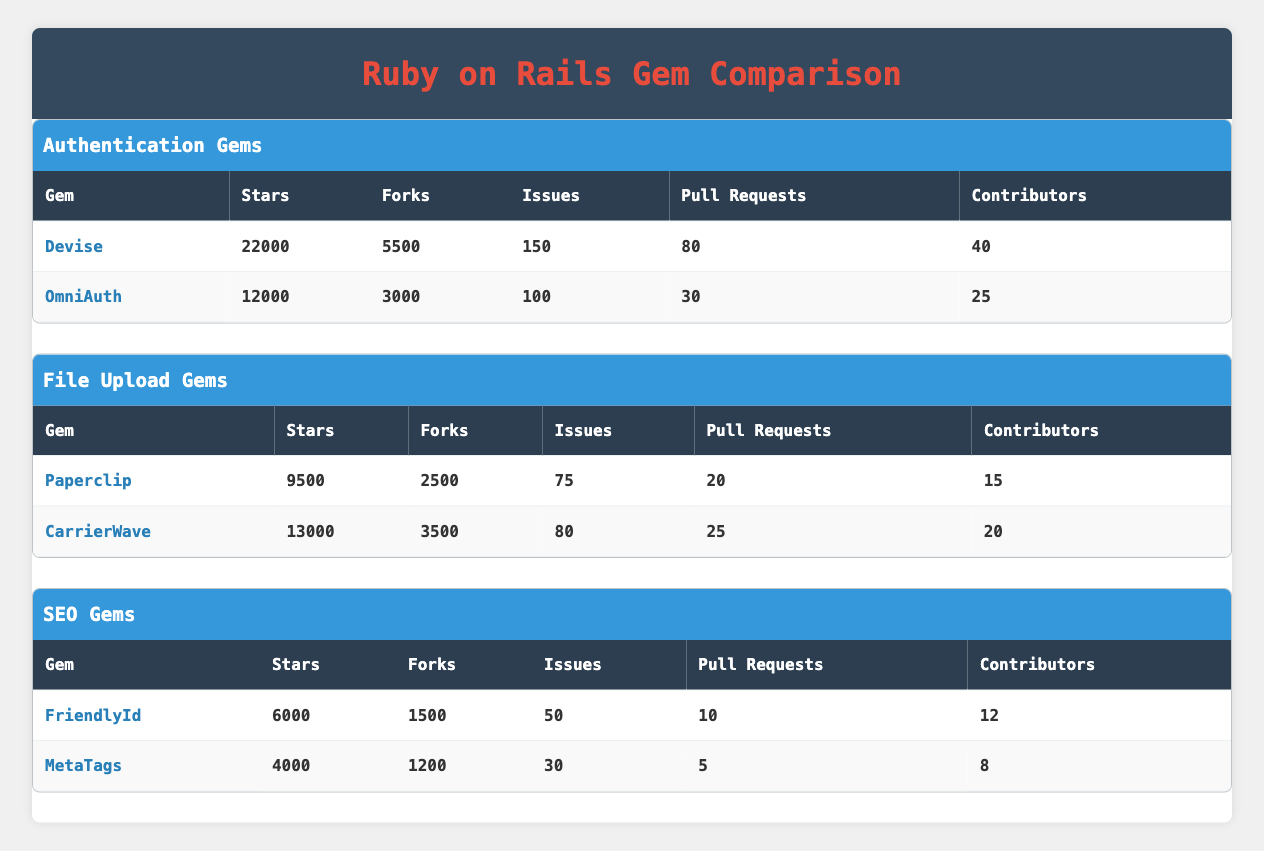What gem has the most stars in the Authentication Gems category? By looking at the "Stars" column under the "Authentication Gems" category, we see that Devise has 22000 stars, while OmniAuth has 12000 stars. Since 22000 is greater than 12000, the gem with the most stars is Devise.
Answer: Devise How many contributors does the File Upload Gems category have in total? To find the total contributors in the "File Upload Gems" category, we add the number of contributors for both gems: Paperclip has 15 contributors and CarrierWave has 20 contributors. So, the total is 15 + 20 = 35.
Answer: 35 Is it true that MetaTags has more forks than FriendlyId? Looking under the "Forks" column for the SEO Gems category, MetaTags has 1200 forks while FriendlyId has 1500 forks. Therefore, it is false that MetaTags has more forks than FriendlyId.
Answer: No What is the average number of issues in the Authentication Gems category? In the Authentication Gems category, Devise has 150 issues and OmniAuth has 100 issues. To calculate the average, we sum the issues: 150 + 100 = 250, and then divide by the number of gems, which is 2. So, 250 / 2 = 125.
Answer: 125 Which gem has the least number of stars in the SEO Gems category? In the SEO Gems category, FriendlyId has 6000 stars and MetaTags has 4000 stars. Comparing these numbers, MetaTags has the least number of stars, with 4000.
Answer: MetaTags How many more pull requests does Devise have than CarrierWave? Devise has 80 pull requests, and CarrierWave has 25. To find out how many more pull requests Devise has, we subtract the number of pull requests for CarrierWave from those of Devise: 80 - 25 = 55.
Answer: 55 Do any gems have more than 5000 stars among the File Upload Gems? Checking the "Stars" column for the File Upload Gems, Paperclip has 9500 stars and CarrierWave has 13000 stars. Both gems have stars exceeding 5000, so the answer is yes.
Answer: Yes What is the difference in contributors between the Authentication Gems? Devise has 40 contributors and OmniAuth has 25 contributors. To find the difference, we subtract the lesser from the greater: 40 - 25 = 15.
Answer: 15 